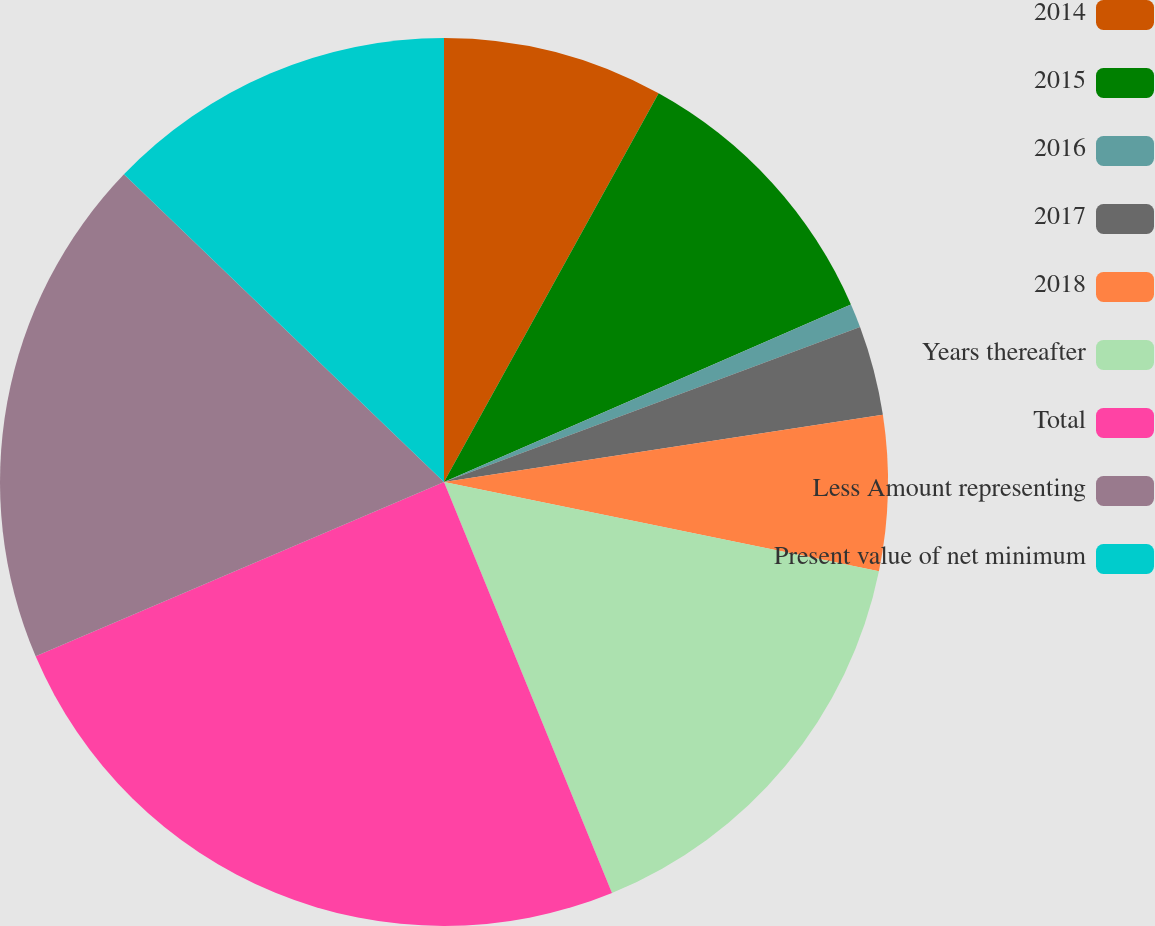<chart> <loc_0><loc_0><loc_500><loc_500><pie_chart><fcel>2014<fcel>2015<fcel>2016<fcel>2017<fcel>2018<fcel>Years thereafter<fcel>Total<fcel>Less Amount representing<fcel>Present value of net minimum<nl><fcel>8.03%<fcel>10.42%<fcel>0.87%<fcel>3.26%<fcel>5.64%<fcel>15.6%<fcel>24.75%<fcel>18.61%<fcel>12.81%<nl></chart> 